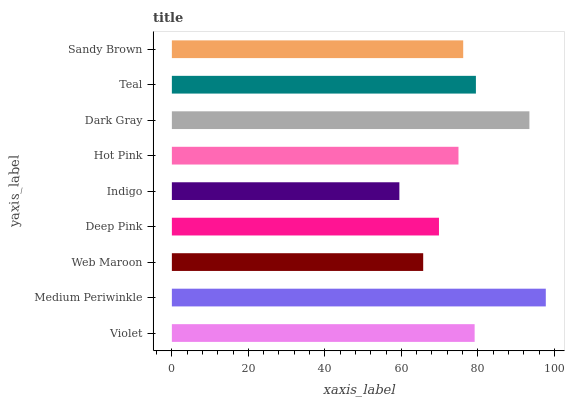Is Indigo the minimum?
Answer yes or no. Yes. Is Medium Periwinkle the maximum?
Answer yes or no. Yes. Is Web Maroon the minimum?
Answer yes or no. No. Is Web Maroon the maximum?
Answer yes or no. No. Is Medium Periwinkle greater than Web Maroon?
Answer yes or no. Yes. Is Web Maroon less than Medium Periwinkle?
Answer yes or no. Yes. Is Web Maroon greater than Medium Periwinkle?
Answer yes or no. No. Is Medium Periwinkle less than Web Maroon?
Answer yes or no. No. Is Sandy Brown the high median?
Answer yes or no. Yes. Is Sandy Brown the low median?
Answer yes or no. Yes. Is Indigo the high median?
Answer yes or no. No. Is Deep Pink the low median?
Answer yes or no. No. 